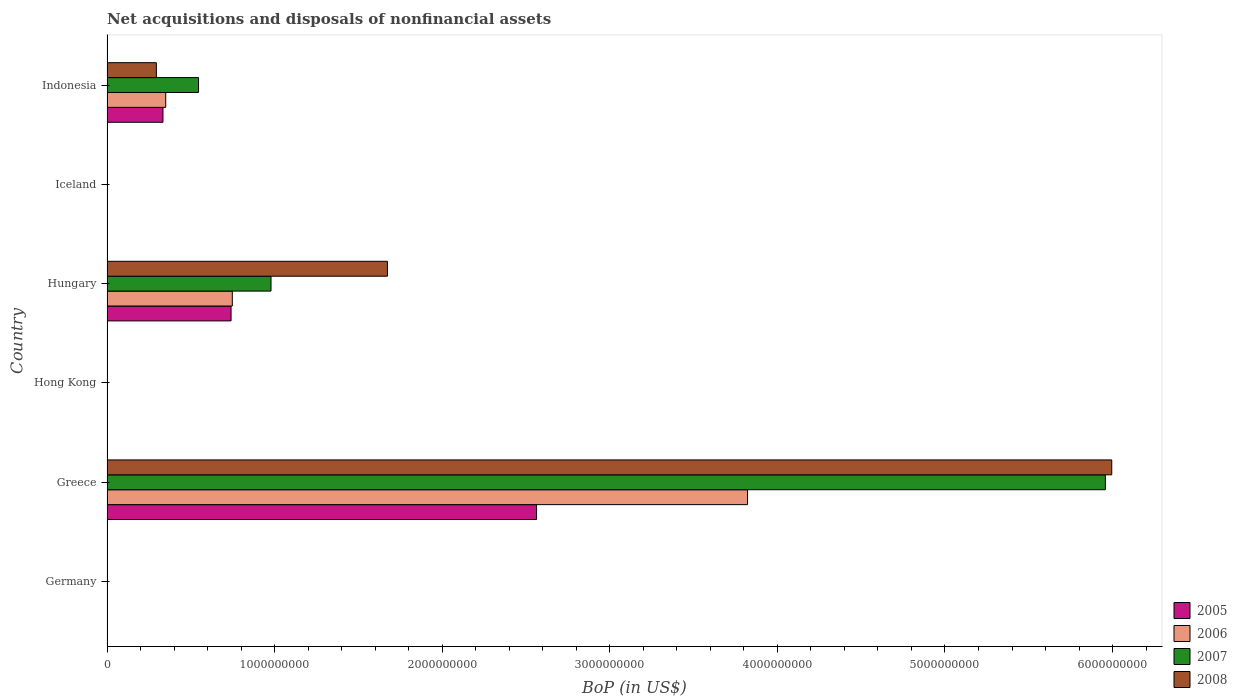How many different coloured bars are there?
Keep it short and to the point. 4. Are the number of bars per tick equal to the number of legend labels?
Ensure brevity in your answer.  No. How many bars are there on the 4th tick from the bottom?
Your answer should be very brief. 4. What is the label of the 5th group of bars from the top?
Provide a succinct answer. Greece. In how many cases, is the number of bars for a given country not equal to the number of legend labels?
Ensure brevity in your answer.  3. What is the Balance of Payments in 2006 in Greece?
Make the answer very short. 3.82e+09. Across all countries, what is the maximum Balance of Payments in 2007?
Offer a very short reply. 5.96e+09. Across all countries, what is the minimum Balance of Payments in 2005?
Your answer should be very brief. 0. What is the total Balance of Payments in 2007 in the graph?
Offer a terse response. 7.48e+09. What is the difference between the Balance of Payments in 2006 in Greece and that in Indonesia?
Provide a short and direct response. 3.47e+09. What is the difference between the Balance of Payments in 2007 in Hungary and the Balance of Payments in 2006 in Indonesia?
Keep it short and to the point. 6.28e+08. What is the average Balance of Payments in 2008 per country?
Your answer should be very brief. 1.33e+09. What is the difference between the Balance of Payments in 2007 and Balance of Payments in 2008 in Hungary?
Keep it short and to the point. -6.95e+08. In how many countries, is the Balance of Payments in 2006 greater than 6000000000 US$?
Provide a succinct answer. 0. What is the ratio of the Balance of Payments in 2007 in Greece to that in Hungary?
Provide a short and direct response. 6.09. What is the difference between the highest and the second highest Balance of Payments in 2008?
Make the answer very short. 4.32e+09. What is the difference between the highest and the lowest Balance of Payments in 2008?
Ensure brevity in your answer.  6.00e+09. Is it the case that in every country, the sum of the Balance of Payments in 2008 and Balance of Payments in 2006 is greater than the Balance of Payments in 2007?
Offer a very short reply. No. How many bars are there?
Give a very brief answer. 12. Are all the bars in the graph horizontal?
Your response must be concise. Yes. How many countries are there in the graph?
Your answer should be very brief. 6. What is the difference between two consecutive major ticks on the X-axis?
Offer a terse response. 1.00e+09. How are the legend labels stacked?
Your response must be concise. Vertical. What is the title of the graph?
Make the answer very short. Net acquisitions and disposals of nonfinancial assets. What is the label or title of the X-axis?
Ensure brevity in your answer.  BoP (in US$). What is the label or title of the Y-axis?
Give a very brief answer. Country. What is the BoP (in US$) in 2005 in Germany?
Keep it short and to the point. 0. What is the BoP (in US$) in 2006 in Germany?
Provide a succinct answer. 0. What is the BoP (in US$) of 2008 in Germany?
Your answer should be very brief. 0. What is the BoP (in US$) in 2005 in Greece?
Provide a succinct answer. 2.56e+09. What is the BoP (in US$) of 2006 in Greece?
Keep it short and to the point. 3.82e+09. What is the BoP (in US$) of 2007 in Greece?
Your answer should be compact. 5.96e+09. What is the BoP (in US$) of 2008 in Greece?
Make the answer very short. 6.00e+09. What is the BoP (in US$) of 2008 in Hong Kong?
Ensure brevity in your answer.  0. What is the BoP (in US$) in 2005 in Hungary?
Give a very brief answer. 7.40e+08. What is the BoP (in US$) of 2006 in Hungary?
Provide a short and direct response. 7.48e+08. What is the BoP (in US$) in 2007 in Hungary?
Offer a terse response. 9.79e+08. What is the BoP (in US$) in 2008 in Hungary?
Your answer should be compact. 1.67e+09. What is the BoP (in US$) of 2007 in Iceland?
Give a very brief answer. 0. What is the BoP (in US$) in 2008 in Iceland?
Offer a terse response. 0. What is the BoP (in US$) in 2005 in Indonesia?
Provide a succinct answer. 3.34e+08. What is the BoP (in US$) of 2006 in Indonesia?
Ensure brevity in your answer.  3.50e+08. What is the BoP (in US$) in 2007 in Indonesia?
Keep it short and to the point. 5.46e+08. What is the BoP (in US$) in 2008 in Indonesia?
Your response must be concise. 2.94e+08. Across all countries, what is the maximum BoP (in US$) in 2005?
Ensure brevity in your answer.  2.56e+09. Across all countries, what is the maximum BoP (in US$) of 2006?
Your answer should be very brief. 3.82e+09. Across all countries, what is the maximum BoP (in US$) of 2007?
Ensure brevity in your answer.  5.96e+09. Across all countries, what is the maximum BoP (in US$) in 2008?
Your answer should be compact. 6.00e+09. Across all countries, what is the minimum BoP (in US$) in 2006?
Your response must be concise. 0. Across all countries, what is the minimum BoP (in US$) in 2007?
Offer a very short reply. 0. Across all countries, what is the minimum BoP (in US$) of 2008?
Ensure brevity in your answer.  0. What is the total BoP (in US$) of 2005 in the graph?
Your response must be concise. 3.64e+09. What is the total BoP (in US$) in 2006 in the graph?
Your answer should be compact. 4.92e+09. What is the total BoP (in US$) in 2007 in the graph?
Provide a short and direct response. 7.48e+09. What is the total BoP (in US$) of 2008 in the graph?
Provide a short and direct response. 7.96e+09. What is the difference between the BoP (in US$) of 2005 in Greece and that in Hungary?
Provide a short and direct response. 1.82e+09. What is the difference between the BoP (in US$) in 2006 in Greece and that in Hungary?
Offer a terse response. 3.07e+09. What is the difference between the BoP (in US$) of 2007 in Greece and that in Hungary?
Offer a very short reply. 4.98e+09. What is the difference between the BoP (in US$) in 2008 in Greece and that in Hungary?
Your response must be concise. 4.32e+09. What is the difference between the BoP (in US$) of 2005 in Greece and that in Indonesia?
Your answer should be very brief. 2.23e+09. What is the difference between the BoP (in US$) of 2006 in Greece and that in Indonesia?
Provide a short and direct response. 3.47e+09. What is the difference between the BoP (in US$) in 2007 in Greece and that in Indonesia?
Provide a succinct answer. 5.41e+09. What is the difference between the BoP (in US$) of 2008 in Greece and that in Indonesia?
Your answer should be very brief. 5.70e+09. What is the difference between the BoP (in US$) in 2005 in Hungary and that in Indonesia?
Your answer should be very brief. 4.06e+08. What is the difference between the BoP (in US$) in 2006 in Hungary and that in Indonesia?
Ensure brevity in your answer.  3.97e+08. What is the difference between the BoP (in US$) in 2007 in Hungary and that in Indonesia?
Your answer should be very brief. 4.32e+08. What is the difference between the BoP (in US$) in 2008 in Hungary and that in Indonesia?
Your answer should be compact. 1.38e+09. What is the difference between the BoP (in US$) of 2005 in Greece and the BoP (in US$) of 2006 in Hungary?
Offer a terse response. 1.82e+09. What is the difference between the BoP (in US$) in 2005 in Greece and the BoP (in US$) in 2007 in Hungary?
Keep it short and to the point. 1.58e+09. What is the difference between the BoP (in US$) in 2005 in Greece and the BoP (in US$) in 2008 in Hungary?
Your answer should be compact. 8.90e+08. What is the difference between the BoP (in US$) of 2006 in Greece and the BoP (in US$) of 2007 in Hungary?
Your answer should be very brief. 2.84e+09. What is the difference between the BoP (in US$) in 2006 in Greece and the BoP (in US$) in 2008 in Hungary?
Offer a terse response. 2.15e+09. What is the difference between the BoP (in US$) in 2007 in Greece and the BoP (in US$) in 2008 in Hungary?
Keep it short and to the point. 4.28e+09. What is the difference between the BoP (in US$) in 2005 in Greece and the BoP (in US$) in 2006 in Indonesia?
Your answer should be very brief. 2.21e+09. What is the difference between the BoP (in US$) in 2005 in Greece and the BoP (in US$) in 2007 in Indonesia?
Provide a succinct answer. 2.02e+09. What is the difference between the BoP (in US$) in 2005 in Greece and the BoP (in US$) in 2008 in Indonesia?
Your answer should be very brief. 2.27e+09. What is the difference between the BoP (in US$) in 2006 in Greece and the BoP (in US$) in 2007 in Indonesia?
Offer a terse response. 3.28e+09. What is the difference between the BoP (in US$) in 2006 in Greece and the BoP (in US$) in 2008 in Indonesia?
Your response must be concise. 3.53e+09. What is the difference between the BoP (in US$) of 2007 in Greece and the BoP (in US$) of 2008 in Indonesia?
Your answer should be compact. 5.66e+09. What is the difference between the BoP (in US$) in 2005 in Hungary and the BoP (in US$) in 2006 in Indonesia?
Your response must be concise. 3.90e+08. What is the difference between the BoP (in US$) in 2005 in Hungary and the BoP (in US$) in 2007 in Indonesia?
Keep it short and to the point. 1.94e+08. What is the difference between the BoP (in US$) of 2005 in Hungary and the BoP (in US$) of 2008 in Indonesia?
Keep it short and to the point. 4.46e+08. What is the difference between the BoP (in US$) of 2006 in Hungary and the BoP (in US$) of 2007 in Indonesia?
Offer a very short reply. 2.01e+08. What is the difference between the BoP (in US$) in 2006 in Hungary and the BoP (in US$) in 2008 in Indonesia?
Your answer should be compact. 4.53e+08. What is the difference between the BoP (in US$) in 2007 in Hungary and the BoP (in US$) in 2008 in Indonesia?
Your response must be concise. 6.84e+08. What is the average BoP (in US$) of 2005 per country?
Your answer should be very brief. 6.06e+08. What is the average BoP (in US$) of 2006 per country?
Give a very brief answer. 8.20e+08. What is the average BoP (in US$) of 2007 per country?
Offer a very short reply. 1.25e+09. What is the average BoP (in US$) in 2008 per country?
Your answer should be very brief. 1.33e+09. What is the difference between the BoP (in US$) in 2005 and BoP (in US$) in 2006 in Greece?
Ensure brevity in your answer.  -1.26e+09. What is the difference between the BoP (in US$) of 2005 and BoP (in US$) of 2007 in Greece?
Your answer should be very brief. -3.39e+09. What is the difference between the BoP (in US$) of 2005 and BoP (in US$) of 2008 in Greece?
Provide a short and direct response. -3.43e+09. What is the difference between the BoP (in US$) of 2006 and BoP (in US$) of 2007 in Greece?
Offer a very short reply. -2.14e+09. What is the difference between the BoP (in US$) in 2006 and BoP (in US$) in 2008 in Greece?
Your response must be concise. -2.17e+09. What is the difference between the BoP (in US$) in 2007 and BoP (in US$) in 2008 in Greece?
Offer a very short reply. -3.82e+07. What is the difference between the BoP (in US$) of 2005 and BoP (in US$) of 2006 in Hungary?
Provide a succinct answer. -7.44e+06. What is the difference between the BoP (in US$) of 2005 and BoP (in US$) of 2007 in Hungary?
Provide a succinct answer. -2.38e+08. What is the difference between the BoP (in US$) in 2005 and BoP (in US$) in 2008 in Hungary?
Make the answer very short. -9.33e+08. What is the difference between the BoP (in US$) in 2006 and BoP (in US$) in 2007 in Hungary?
Provide a succinct answer. -2.31e+08. What is the difference between the BoP (in US$) of 2006 and BoP (in US$) of 2008 in Hungary?
Offer a terse response. -9.26e+08. What is the difference between the BoP (in US$) of 2007 and BoP (in US$) of 2008 in Hungary?
Give a very brief answer. -6.95e+08. What is the difference between the BoP (in US$) in 2005 and BoP (in US$) in 2006 in Indonesia?
Keep it short and to the point. -1.64e+07. What is the difference between the BoP (in US$) in 2005 and BoP (in US$) in 2007 in Indonesia?
Your answer should be very brief. -2.12e+08. What is the difference between the BoP (in US$) of 2005 and BoP (in US$) of 2008 in Indonesia?
Offer a very short reply. 3.95e+07. What is the difference between the BoP (in US$) in 2006 and BoP (in US$) in 2007 in Indonesia?
Your answer should be very brief. -1.96e+08. What is the difference between the BoP (in US$) of 2006 and BoP (in US$) of 2008 in Indonesia?
Offer a terse response. 5.59e+07. What is the difference between the BoP (in US$) of 2007 and BoP (in US$) of 2008 in Indonesia?
Provide a short and direct response. 2.52e+08. What is the ratio of the BoP (in US$) in 2005 in Greece to that in Hungary?
Your response must be concise. 3.46. What is the ratio of the BoP (in US$) in 2006 in Greece to that in Hungary?
Keep it short and to the point. 5.11. What is the ratio of the BoP (in US$) of 2007 in Greece to that in Hungary?
Make the answer very short. 6.09. What is the ratio of the BoP (in US$) in 2008 in Greece to that in Hungary?
Provide a succinct answer. 3.58. What is the ratio of the BoP (in US$) in 2005 in Greece to that in Indonesia?
Give a very brief answer. 7.68. What is the ratio of the BoP (in US$) of 2006 in Greece to that in Indonesia?
Offer a very short reply. 10.91. What is the ratio of the BoP (in US$) in 2007 in Greece to that in Indonesia?
Keep it short and to the point. 10.91. What is the ratio of the BoP (in US$) in 2008 in Greece to that in Indonesia?
Your response must be concise. 20.36. What is the ratio of the BoP (in US$) of 2005 in Hungary to that in Indonesia?
Provide a short and direct response. 2.22. What is the ratio of the BoP (in US$) of 2006 in Hungary to that in Indonesia?
Provide a succinct answer. 2.13. What is the ratio of the BoP (in US$) in 2007 in Hungary to that in Indonesia?
Keep it short and to the point. 1.79. What is the ratio of the BoP (in US$) of 2008 in Hungary to that in Indonesia?
Your answer should be compact. 5.68. What is the difference between the highest and the second highest BoP (in US$) in 2005?
Your response must be concise. 1.82e+09. What is the difference between the highest and the second highest BoP (in US$) in 2006?
Ensure brevity in your answer.  3.07e+09. What is the difference between the highest and the second highest BoP (in US$) of 2007?
Your answer should be very brief. 4.98e+09. What is the difference between the highest and the second highest BoP (in US$) of 2008?
Give a very brief answer. 4.32e+09. What is the difference between the highest and the lowest BoP (in US$) of 2005?
Provide a short and direct response. 2.56e+09. What is the difference between the highest and the lowest BoP (in US$) of 2006?
Offer a terse response. 3.82e+09. What is the difference between the highest and the lowest BoP (in US$) of 2007?
Offer a terse response. 5.96e+09. What is the difference between the highest and the lowest BoP (in US$) in 2008?
Offer a very short reply. 6.00e+09. 